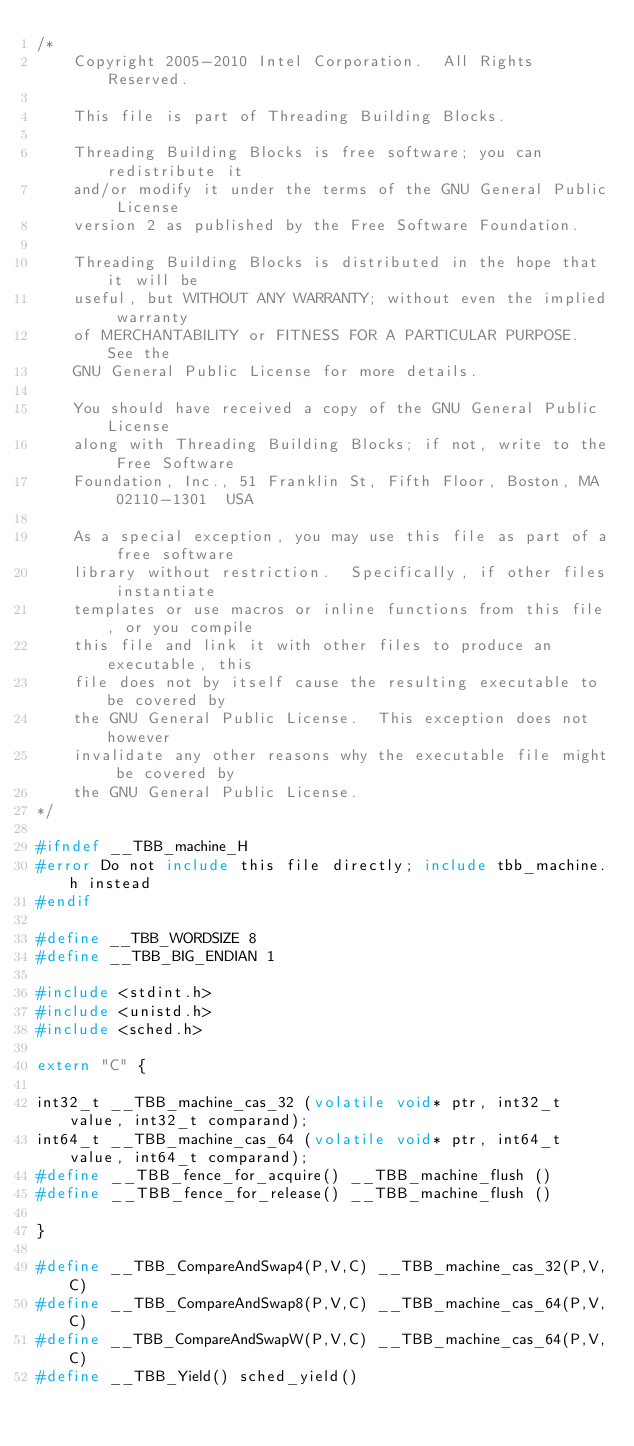<code> <loc_0><loc_0><loc_500><loc_500><_C_>/*
    Copyright 2005-2010 Intel Corporation.  All Rights Reserved.

    This file is part of Threading Building Blocks.

    Threading Building Blocks is free software; you can redistribute it
    and/or modify it under the terms of the GNU General Public License
    version 2 as published by the Free Software Foundation.

    Threading Building Blocks is distributed in the hope that it will be
    useful, but WITHOUT ANY WARRANTY; without even the implied warranty
    of MERCHANTABILITY or FITNESS FOR A PARTICULAR PURPOSE.  See the
    GNU General Public License for more details.

    You should have received a copy of the GNU General Public License
    along with Threading Building Blocks; if not, write to the Free Software
    Foundation, Inc., 51 Franklin St, Fifth Floor, Boston, MA  02110-1301  USA

    As a special exception, you may use this file as part of a free software
    library without restriction.  Specifically, if other files instantiate
    templates or use macros or inline functions from this file, or you compile
    this file and link it with other files to produce an executable, this
    file does not by itself cause the resulting executable to be covered by
    the GNU General Public License.  This exception does not however
    invalidate any other reasons why the executable file might be covered by
    the GNU General Public License.
*/

#ifndef __TBB_machine_H
#error Do not include this file directly; include tbb_machine.h instead
#endif

#define __TBB_WORDSIZE 8
#define __TBB_BIG_ENDIAN 1

#include <stdint.h>
#include <unistd.h>
#include <sched.h>

extern "C" {

int32_t __TBB_machine_cas_32 (volatile void* ptr, int32_t value, int32_t comparand);
int64_t __TBB_machine_cas_64 (volatile void* ptr, int64_t value, int64_t comparand);
#define __TBB_fence_for_acquire() __TBB_machine_flush ()
#define __TBB_fence_for_release() __TBB_machine_flush ()

}

#define __TBB_CompareAndSwap4(P,V,C) __TBB_machine_cas_32(P,V,C)
#define __TBB_CompareAndSwap8(P,V,C) __TBB_machine_cas_64(P,V,C)
#define __TBB_CompareAndSwapW(P,V,C) __TBB_machine_cas_64(P,V,C)
#define __TBB_Yield() sched_yield()
</code> 